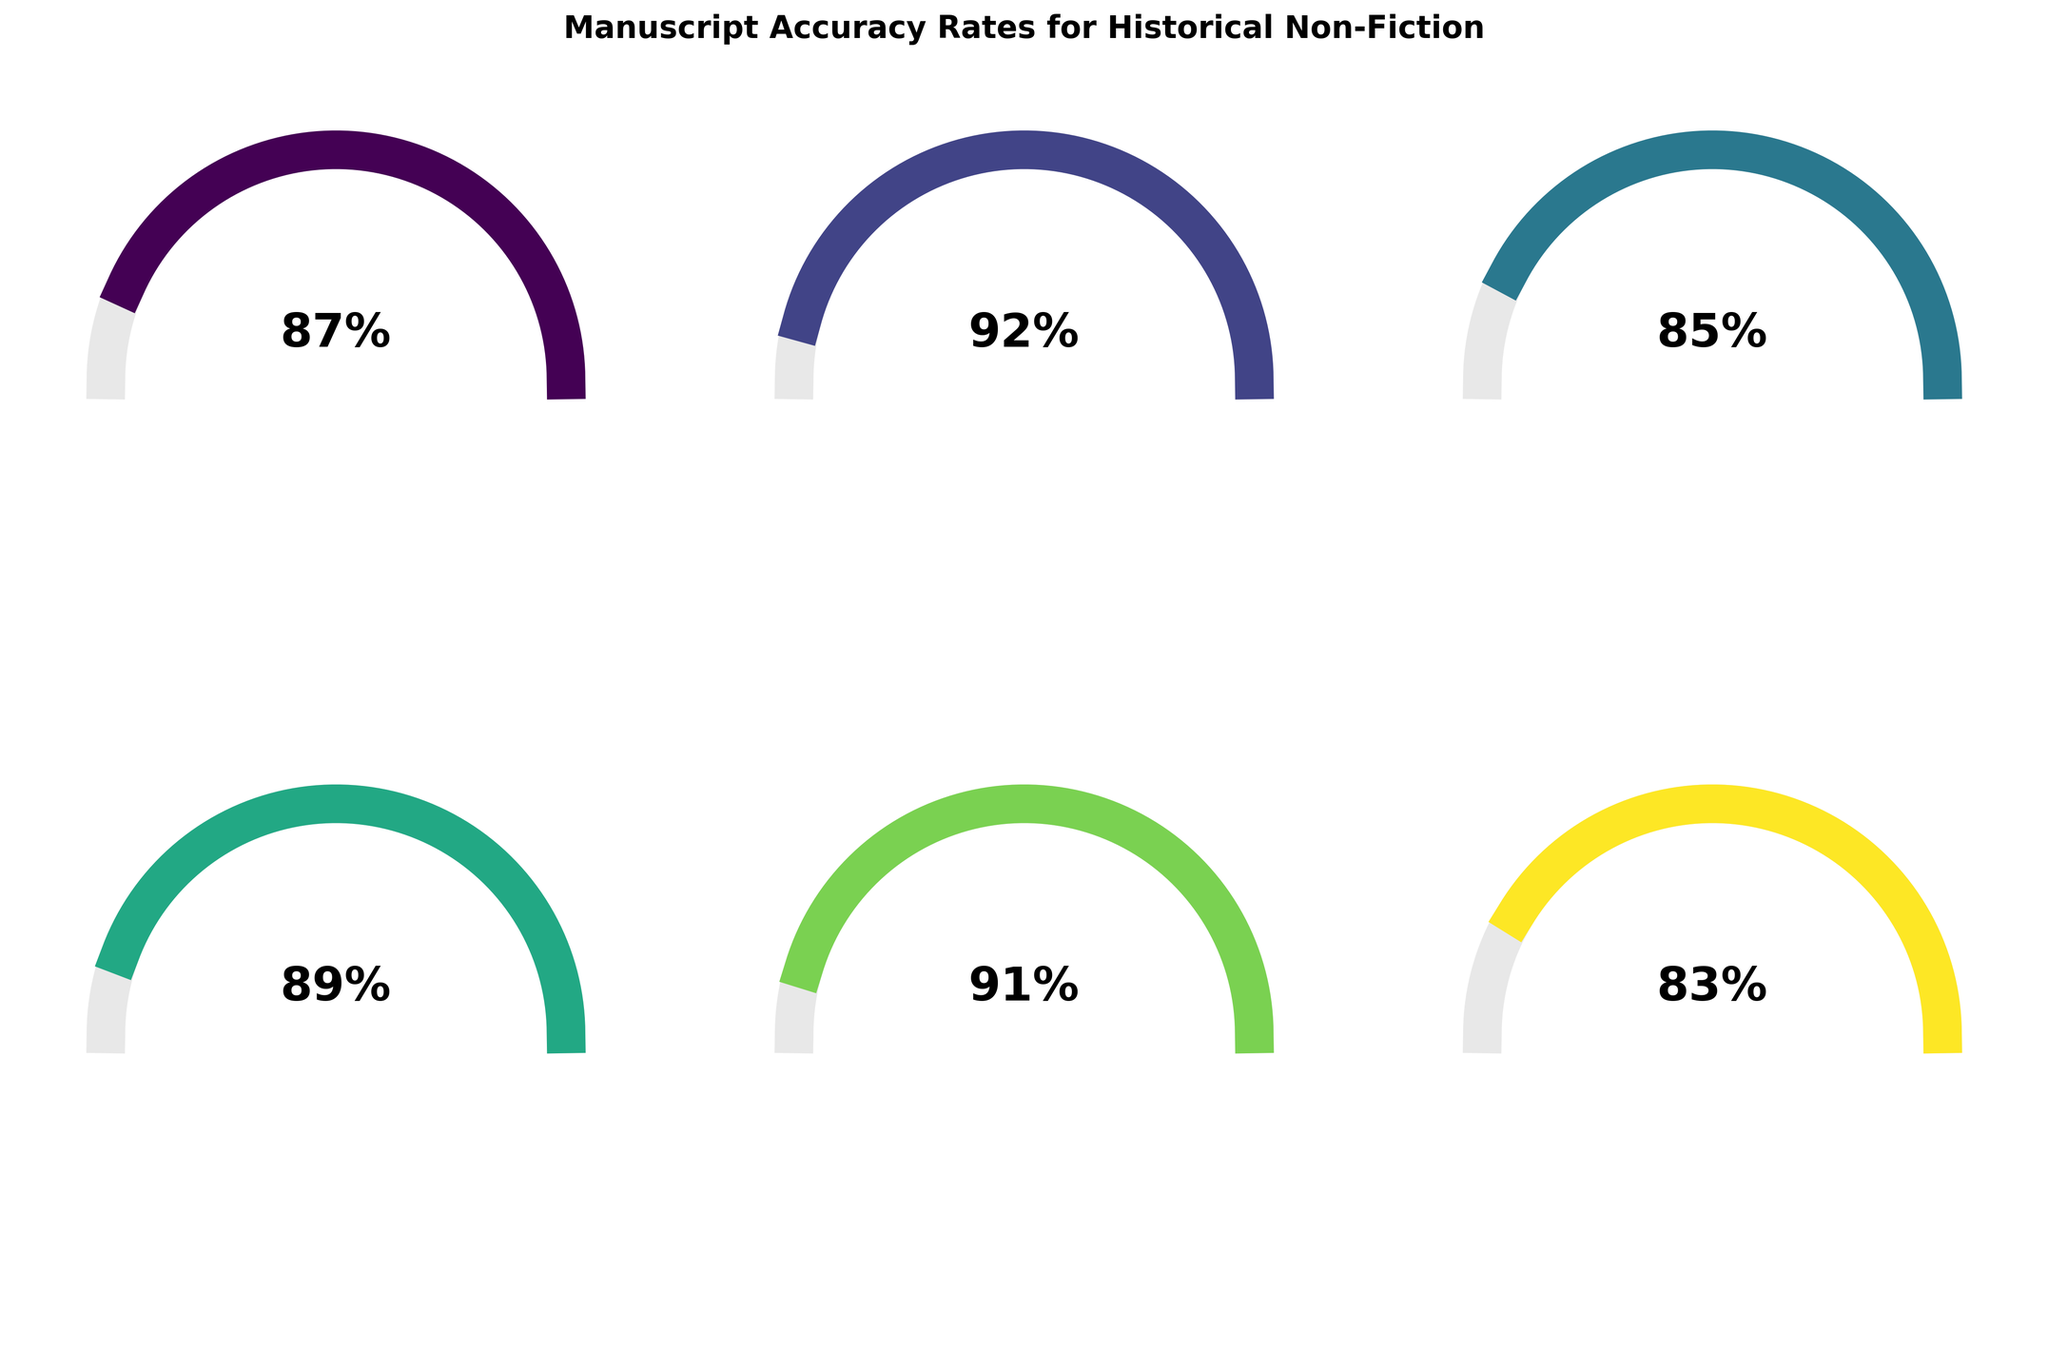What is the overall accuracy rate for the manuscripts? The "Overall Accuracy Rate" gauge shows a value of 87%.
Answer: 87% Which metric has the lowest accuracy rate? The gauge for "Social History Accuracy" shows the lowest value at 83%.
Answer: Social History Accuracy How much higher is the Ancient History Accuracy rate compared to the Medieval History Accuracy rate? The "Ancient History Accuracy" rate is 92%, and the "Medieval History Accuracy" rate is 85%. The difference is 92% - 85% = 7%.
Answer: 7% What is the average accuracy rate across all the metrics presented? Summing up all the accuracy rates: (87 + 92 + 85 + 89 + 91 + 83) = 527, and there are 6 metrics. The average is 527 / 6 ≈ 87.83%.
Answer: 87.83% Which historical category has the closest accuracy rate to the overall accuracy rate? The "Medieval History Accuracy" is 85%, which is the closest to the "Overall Accuracy Rate" of 87%.
Answer: Medieval History Accuracy Is the Military History Accuracy rate greater than the Modern History Accuracy rate? The "Military History Accuracy" rate is 91%, and the "Modern History Accuracy" rate is 89%. Since 91 > 89, Military History Accuracy is greater.
Answer: Yes Are any of the categories depicted with the maximum possible value of 100%? All the gauges in the figure have values less than 100%.
Answer: No How do the accuracy rates for Ancient History and Social History compare? The "Ancient History Accuracy" rate is 92%, and the "Social History Accuracy" rate is 83%. Since 92 > 83, Ancient History Accuracy is higher.
Answer: Ancient History Accuracy is higher What is the range of the accuracy rates shown in the figure? The lowest accuracy rate shown is 83% (Social History), and the highest is 92% (Ancient History). The range is 92% - 83% = 9%.
Answer: 9% Which metric is shown second from the left in the top row of the gauges? The second gauge from the left in the top row is labeled "Ancient History Accuracy".
Answer: Ancient History Accuracy 